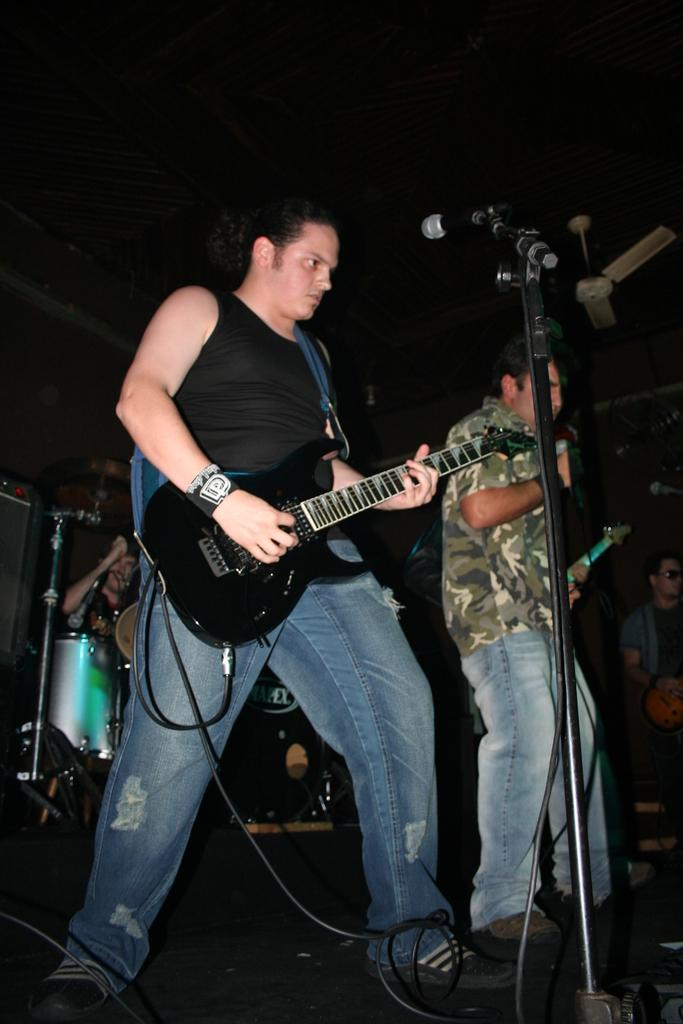What is happening on the stage in the image? There are people on the stage, and they are performing. What are the people doing while performing? The people are playing musical instruments. How many kittens are playing with the son on the stage in the image? There are no kittens or a son present on the stage in the image; it only shows people playing musical instruments. 